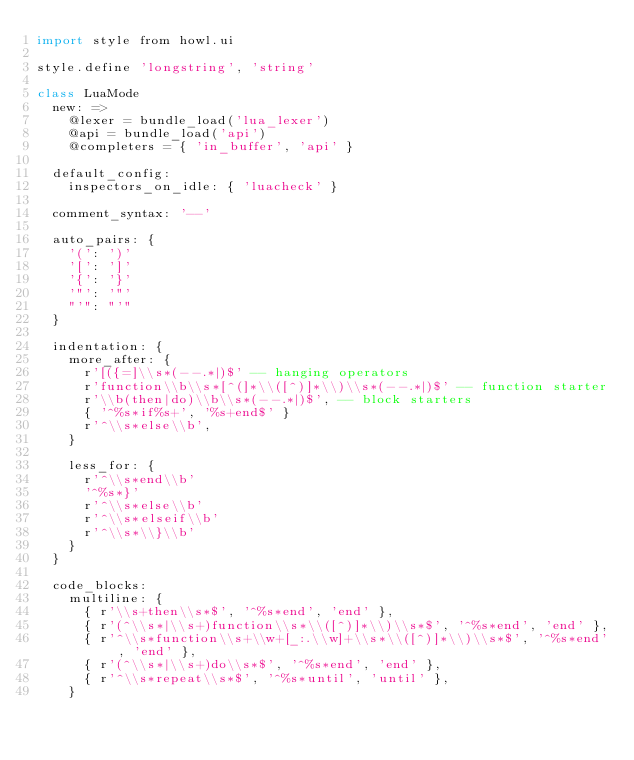Convert code to text. <code><loc_0><loc_0><loc_500><loc_500><_MoonScript_>import style from howl.ui

style.define 'longstring', 'string'

class LuaMode
  new: =>
    @lexer = bundle_load('lua_lexer')
    @api = bundle_load('api')
    @completers = { 'in_buffer', 'api' }

  default_config:
    inspectors_on_idle: { 'luacheck' }

  comment_syntax: '--'

  auto_pairs: {
    '(': ')'
    '[': ']'
    '{': '}'
    '"': '"'
    "'": "'"
  }

  indentation: {
    more_after: {
      r'[({=]\\s*(--.*|)$' -- hanging operators
      r'function\\b\\s*[^(]*\\([^)]*\\)\\s*(--.*|)$' -- function starter
      r'\\b(then|do)\\b\\s*(--.*|)$', -- block starters
      { '^%s*if%s+', '%s+end$' }
      r'^\\s*else\\b',
    }

    less_for: {
      r'^\\s*end\\b'
      '^%s*}'
      r'^\\s*else\\b'
      r'^\\s*elseif\\b'
      r'^\\s*\\}\\b'
    }
  }

  code_blocks:
    multiline: {
      { r'\\s+then\\s*$', '^%s*end', 'end' },
      { r'(^\\s*|\\s+)function\\s*\\([^)]*\\)\\s*$', '^%s*end', 'end' },
      { r'^\\s*function\\s+\\w+[_:.\\w]+\\s*\\([^)]*\\)\\s*$', '^%s*end', 'end' },
      { r'(^\\s*|\\s+)do\\s*$', '^%s*end', 'end' },
      { r'^\\s*repeat\\s*$', '^%s*until', 'until' },
    }
</code> 